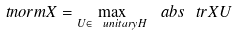Convert formula to latex. <formula><loc_0><loc_0><loc_500><loc_500>\ t n o r m { X } = \max _ { U \in \ u n i t a r y { H } } \ a b s { \ t r X U }</formula> 